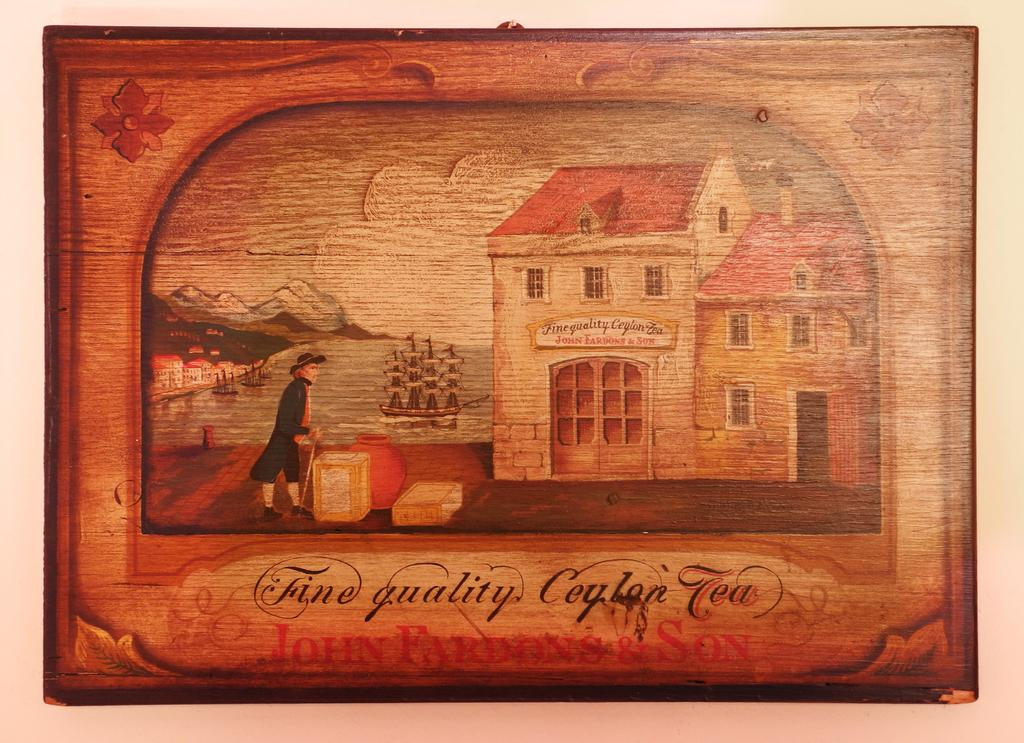<image>
Relay a brief, clear account of the picture shown. an old fashioned advert for 'quality ceylon tea' 